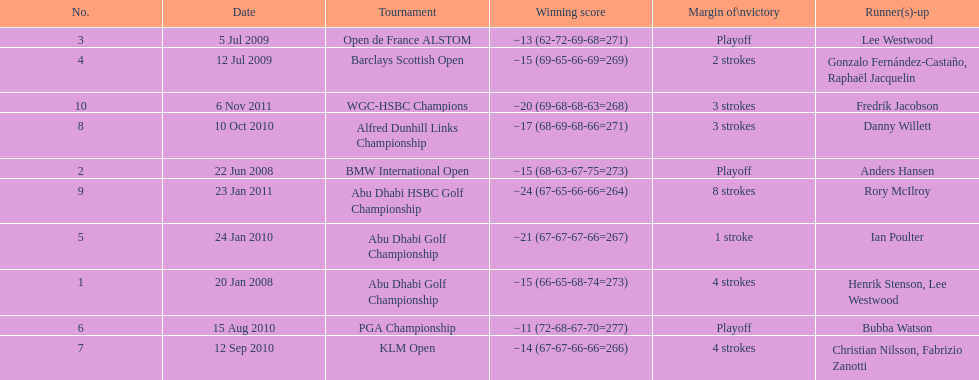How many winning scores were less than -14? 2. Parse the table in full. {'header': ['No.', 'Date', 'Tournament', 'Winning score', 'Margin of\\nvictory', 'Runner(s)-up'], 'rows': [['3', '5 Jul 2009', 'Open de France ALSTOM', '−13 (62-72-69-68=271)', 'Playoff', 'Lee Westwood'], ['4', '12 Jul 2009', 'Barclays Scottish Open', '−15 (69-65-66-69=269)', '2 strokes', 'Gonzalo Fernández-Castaño, Raphaël Jacquelin'], ['10', '6 Nov 2011', 'WGC-HSBC Champions', '−20 (69-68-68-63=268)', '3 strokes', 'Fredrik Jacobson'], ['8', '10 Oct 2010', 'Alfred Dunhill Links Championship', '−17 (68-69-68-66=271)', '3 strokes', 'Danny Willett'], ['2', '22 Jun 2008', 'BMW International Open', '−15 (68-63-67-75=273)', 'Playoff', 'Anders Hansen'], ['9', '23 Jan 2011', 'Abu Dhabi HSBC Golf Championship', '−24 (67-65-66-66=264)', '8 strokes', 'Rory McIlroy'], ['5', '24 Jan 2010', 'Abu Dhabi Golf Championship', '−21 (67-67-67-66=267)', '1 stroke', 'Ian Poulter'], ['1', '20 Jan 2008', 'Abu Dhabi Golf Championship', '−15 (66-65-68-74=273)', '4 strokes', 'Henrik Stenson, Lee Westwood'], ['6', '15 Aug 2010', 'PGA Championship', '−11 (72-68-67-70=277)', 'Playoff', 'Bubba Watson'], ['7', '12 Sep 2010', 'KLM Open', '−14 (67-67-66-66=266)', '4 strokes', 'Christian Nilsson, Fabrizio Zanotti']]} 